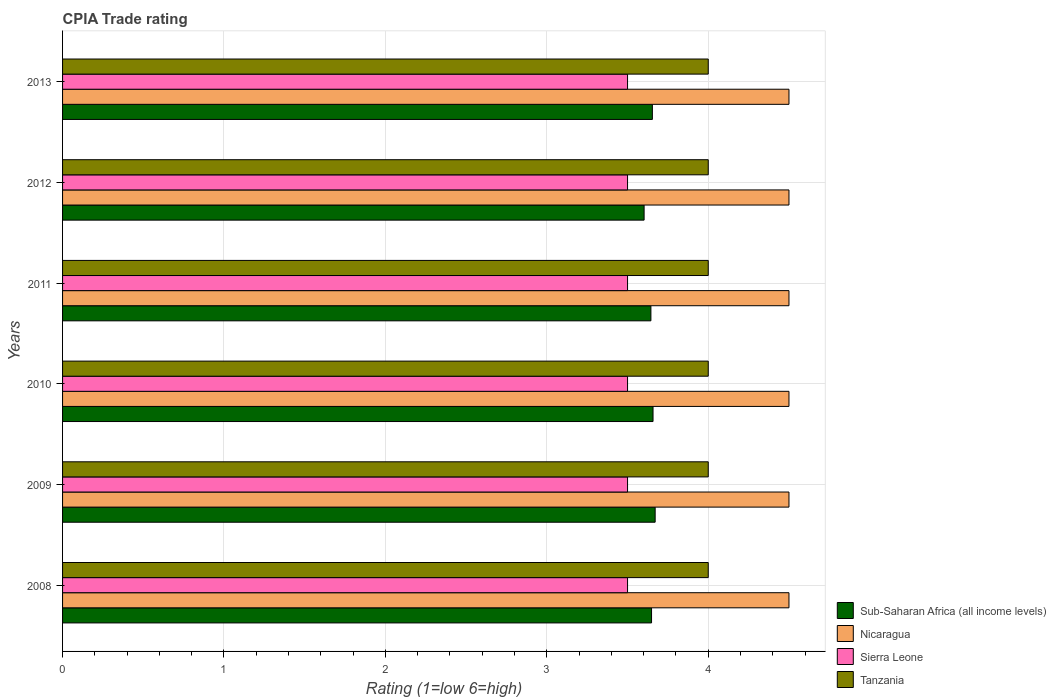How many groups of bars are there?
Ensure brevity in your answer.  6. Are the number of bars per tick equal to the number of legend labels?
Make the answer very short. Yes. How many bars are there on the 5th tick from the top?
Provide a succinct answer. 4. In how many cases, is the number of bars for a given year not equal to the number of legend labels?
Offer a terse response. 0. What is the CPIA rating in Sub-Saharan Africa (all income levels) in 2010?
Provide a succinct answer. 3.66. Across all years, what is the maximum CPIA rating in Tanzania?
Provide a short and direct response. 4. What is the difference between the CPIA rating in Sub-Saharan Africa (all income levels) in 2011 and that in 2013?
Ensure brevity in your answer.  -0.01. What is the difference between the CPIA rating in Sub-Saharan Africa (all income levels) in 2010 and the CPIA rating in Tanzania in 2012?
Offer a terse response. -0.34. What is the average CPIA rating in Sub-Saharan Africa (all income levels) per year?
Offer a very short reply. 3.65. In the year 2013, what is the difference between the CPIA rating in Tanzania and CPIA rating in Nicaragua?
Offer a terse response. -0.5. What is the difference between the highest and the second highest CPIA rating in Sierra Leone?
Offer a terse response. 0. What is the difference between the highest and the lowest CPIA rating in Nicaragua?
Your answer should be very brief. 0. In how many years, is the CPIA rating in Tanzania greater than the average CPIA rating in Tanzania taken over all years?
Provide a short and direct response. 0. What does the 3rd bar from the top in 2013 represents?
Give a very brief answer. Nicaragua. What does the 4th bar from the bottom in 2010 represents?
Your answer should be compact. Tanzania. Are all the bars in the graph horizontal?
Keep it short and to the point. Yes. How many years are there in the graph?
Make the answer very short. 6. Are the values on the major ticks of X-axis written in scientific E-notation?
Ensure brevity in your answer.  No. Does the graph contain grids?
Your answer should be very brief. Yes. Where does the legend appear in the graph?
Your response must be concise. Bottom right. How are the legend labels stacked?
Provide a succinct answer. Vertical. What is the title of the graph?
Provide a short and direct response. CPIA Trade rating. What is the label or title of the Y-axis?
Offer a terse response. Years. What is the Rating (1=low 6=high) in Sub-Saharan Africa (all income levels) in 2008?
Give a very brief answer. 3.65. What is the Rating (1=low 6=high) of Sub-Saharan Africa (all income levels) in 2009?
Provide a succinct answer. 3.67. What is the Rating (1=low 6=high) of Sierra Leone in 2009?
Offer a very short reply. 3.5. What is the Rating (1=low 6=high) of Sub-Saharan Africa (all income levels) in 2010?
Give a very brief answer. 3.66. What is the Rating (1=low 6=high) in Nicaragua in 2010?
Offer a very short reply. 4.5. What is the Rating (1=low 6=high) of Sierra Leone in 2010?
Provide a succinct answer. 3.5. What is the Rating (1=low 6=high) in Sub-Saharan Africa (all income levels) in 2011?
Keep it short and to the point. 3.64. What is the Rating (1=low 6=high) in Nicaragua in 2011?
Ensure brevity in your answer.  4.5. What is the Rating (1=low 6=high) in Tanzania in 2011?
Your answer should be compact. 4. What is the Rating (1=low 6=high) in Sub-Saharan Africa (all income levels) in 2012?
Provide a succinct answer. 3.6. What is the Rating (1=low 6=high) in Nicaragua in 2012?
Your response must be concise. 4.5. What is the Rating (1=low 6=high) in Sierra Leone in 2012?
Ensure brevity in your answer.  3.5. What is the Rating (1=low 6=high) of Sub-Saharan Africa (all income levels) in 2013?
Ensure brevity in your answer.  3.65. What is the Rating (1=low 6=high) of Sierra Leone in 2013?
Provide a succinct answer. 3.5. What is the Rating (1=low 6=high) of Tanzania in 2013?
Ensure brevity in your answer.  4. Across all years, what is the maximum Rating (1=low 6=high) in Sub-Saharan Africa (all income levels)?
Your answer should be compact. 3.67. Across all years, what is the maximum Rating (1=low 6=high) in Nicaragua?
Provide a short and direct response. 4.5. Across all years, what is the minimum Rating (1=low 6=high) in Sub-Saharan Africa (all income levels)?
Offer a very short reply. 3.6. Across all years, what is the minimum Rating (1=low 6=high) of Nicaragua?
Keep it short and to the point. 4.5. Across all years, what is the minimum Rating (1=low 6=high) in Sierra Leone?
Your answer should be very brief. 3.5. Across all years, what is the minimum Rating (1=low 6=high) of Tanzania?
Make the answer very short. 4. What is the total Rating (1=low 6=high) in Sub-Saharan Africa (all income levels) in the graph?
Provide a short and direct response. 21.88. What is the total Rating (1=low 6=high) in Nicaragua in the graph?
Make the answer very short. 27. What is the total Rating (1=low 6=high) in Sierra Leone in the graph?
Your answer should be compact. 21. What is the difference between the Rating (1=low 6=high) in Sub-Saharan Africa (all income levels) in 2008 and that in 2009?
Keep it short and to the point. -0.02. What is the difference between the Rating (1=low 6=high) in Nicaragua in 2008 and that in 2009?
Provide a succinct answer. 0. What is the difference between the Rating (1=low 6=high) in Sub-Saharan Africa (all income levels) in 2008 and that in 2010?
Your answer should be compact. -0.01. What is the difference between the Rating (1=low 6=high) in Nicaragua in 2008 and that in 2010?
Offer a terse response. 0. What is the difference between the Rating (1=low 6=high) of Sierra Leone in 2008 and that in 2010?
Your answer should be compact. 0. What is the difference between the Rating (1=low 6=high) of Sub-Saharan Africa (all income levels) in 2008 and that in 2011?
Provide a succinct answer. 0. What is the difference between the Rating (1=low 6=high) of Nicaragua in 2008 and that in 2011?
Give a very brief answer. 0. What is the difference between the Rating (1=low 6=high) in Sierra Leone in 2008 and that in 2011?
Make the answer very short. 0. What is the difference between the Rating (1=low 6=high) of Sub-Saharan Africa (all income levels) in 2008 and that in 2012?
Make the answer very short. 0.05. What is the difference between the Rating (1=low 6=high) in Sub-Saharan Africa (all income levels) in 2008 and that in 2013?
Ensure brevity in your answer.  -0.01. What is the difference between the Rating (1=low 6=high) of Sierra Leone in 2008 and that in 2013?
Offer a very short reply. 0. What is the difference between the Rating (1=low 6=high) in Tanzania in 2008 and that in 2013?
Your answer should be compact. 0. What is the difference between the Rating (1=low 6=high) in Sub-Saharan Africa (all income levels) in 2009 and that in 2010?
Keep it short and to the point. 0.01. What is the difference between the Rating (1=low 6=high) of Sierra Leone in 2009 and that in 2010?
Offer a very short reply. 0. What is the difference between the Rating (1=low 6=high) of Tanzania in 2009 and that in 2010?
Make the answer very short. 0. What is the difference between the Rating (1=low 6=high) in Sub-Saharan Africa (all income levels) in 2009 and that in 2011?
Make the answer very short. 0.03. What is the difference between the Rating (1=low 6=high) of Nicaragua in 2009 and that in 2011?
Provide a short and direct response. 0. What is the difference between the Rating (1=low 6=high) of Tanzania in 2009 and that in 2011?
Provide a succinct answer. 0. What is the difference between the Rating (1=low 6=high) in Sub-Saharan Africa (all income levels) in 2009 and that in 2012?
Ensure brevity in your answer.  0.07. What is the difference between the Rating (1=low 6=high) in Nicaragua in 2009 and that in 2012?
Make the answer very short. 0. What is the difference between the Rating (1=low 6=high) in Sierra Leone in 2009 and that in 2012?
Provide a short and direct response. 0. What is the difference between the Rating (1=low 6=high) in Sub-Saharan Africa (all income levels) in 2009 and that in 2013?
Give a very brief answer. 0.02. What is the difference between the Rating (1=low 6=high) of Nicaragua in 2009 and that in 2013?
Offer a very short reply. 0. What is the difference between the Rating (1=low 6=high) in Sierra Leone in 2009 and that in 2013?
Offer a very short reply. 0. What is the difference between the Rating (1=low 6=high) of Sub-Saharan Africa (all income levels) in 2010 and that in 2011?
Offer a very short reply. 0.01. What is the difference between the Rating (1=low 6=high) of Sierra Leone in 2010 and that in 2011?
Make the answer very short. 0. What is the difference between the Rating (1=low 6=high) of Tanzania in 2010 and that in 2011?
Provide a short and direct response. 0. What is the difference between the Rating (1=low 6=high) in Sub-Saharan Africa (all income levels) in 2010 and that in 2012?
Your response must be concise. 0.06. What is the difference between the Rating (1=low 6=high) in Nicaragua in 2010 and that in 2012?
Offer a terse response. 0. What is the difference between the Rating (1=low 6=high) in Sierra Leone in 2010 and that in 2012?
Give a very brief answer. 0. What is the difference between the Rating (1=low 6=high) in Tanzania in 2010 and that in 2012?
Make the answer very short. 0. What is the difference between the Rating (1=low 6=high) in Sub-Saharan Africa (all income levels) in 2010 and that in 2013?
Ensure brevity in your answer.  0. What is the difference between the Rating (1=low 6=high) in Sierra Leone in 2010 and that in 2013?
Your answer should be very brief. 0. What is the difference between the Rating (1=low 6=high) in Tanzania in 2010 and that in 2013?
Your answer should be compact. 0. What is the difference between the Rating (1=low 6=high) of Sub-Saharan Africa (all income levels) in 2011 and that in 2012?
Give a very brief answer. 0.04. What is the difference between the Rating (1=low 6=high) of Tanzania in 2011 and that in 2012?
Give a very brief answer. 0. What is the difference between the Rating (1=low 6=high) of Sub-Saharan Africa (all income levels) in 2011 and that in 2013?
Offer a terse response. -0.01. What is the difference between the Rating (1=low 6=high) in Nicaragua in 2011 and that in 2013?
Offer a terse response. 0. What is the difference between the Rating (1=low 6=high) in Sierra Leone in 2011 and that in 2013?
Provide a short and direct response. 0. What is the difference between the Rating (1=low 6=high) of Tanzania in 2011 and that in 2013?
Provide a succinct answer. 0. What is the difference between the Rating (1=low 6=high) of Sub-Saharan Africa (all income levels) in 2012 and that in 2013?
Offer a very short reply. -0.05. What is the difference between the Rating (1=low 6=high) of Tanzania in 2012 and that in 2013?
Your answer should be compact. 0. What is the difference between the Rating (1=low 6=high) of Sub-Saharan Africa (all income levels) in 2008 and the Rating (1=low 6=high) of Nicaragua in 2009?
Offer a very short reply. -0.85. What is the difference between the Rating (1=low 6=high) of Sub-Saharan Africa (all income levels) in 2008 and the Rating (1=low 6=high) of Sierra Leone in 2009?
Offer a terse response. 0.15. What is the difference between the Rating (1=low 6=high) in Sub-Saharan Africa (all income levels) in 2008 and the Rating (1=low 6=high) in Tanzania in 2009?
Provide a succinct answer. -0.35. What is the difference between the Rating (1=low 6=high) of Sub-Saharan Africa (all income levels) in 2008 and the Rating (1=low 6=high) of Nicaragua in 2010?
Give a very brief answer. -0.85. What is the difference between the Rating (1=low 6=high) in Sub-Saharan Africa (all income levels) in 2008 and the Rating (1=low 6=high) in Sierra Leone in 2010?
Offer a terse response. 0.15. What is the difference between the Rating (1=low 6=high) of Sub-Saharan Africa (all income levels) in 2008 and the Rating (1=low 6=high) of Tanzania in 2010?
Your answer should be compact. -0.35. What is the difference between the Rating (1=low 6=high) of Sub-Saharan Africa (all income levels) in 2008 and the Rating (1=low 6=high) of Nicaragua in 2011?
Give a very brief answer. -0.85. What is the difference between the Rating (1=low 6=high) of Sub-Saharan Africa (all income levels) in 2008 and the Rating (1=low 6=high) of Sierra Leone in 2011?
Ensure brevity in your answer.  0.15. What is the difference between the Rating (1=low 6=high) of Sub-Saharan Africa (all income levels) in 2008 and the Rating (1=low 6=high) of Tanzania in 2011?
Offer a terse response. -0.35. What is the difference between the Rating (1=low 6=high) in Nicaragua in 2008 and the Rating (1=low 6=high) in Sierra Leone in 2011?
Make the answer very short. 1. What is the difference between the Rating (1=low 6=high) of Nicaragua in 2008 and the Rating (1=low 6=high) of Tanzania in 2011?
Keep it short and to the point. 0.5. What is the difference between the Rating (1=low 6=high) of Sub-Saharan Africa (all income levels) in 2008 and the Rating (1=low 6=high) of Nicaragua in 2012?
Provide a short and direct response. -0.85. What is the difference between the Rating (1=low 6=high) of Sub-Saharan Africa (all income levels) in 2008 and the Rating (1=low 6=high) of Sierra Leone in 2012?
Offer a terse response. 0.15. What is the difference between the Rating (1=low 6=high) in Sub-Saharan Africa (all income levels) in 2008 and the Rating (1=low 6=high) in Tanzania in 2012?
Your answer should be very brief. -0.35. What is the difference between the Rating (1=low 6=high) in Nicaragua in 2008 and the Rating (1=low 6=high) in Sierra Leone in 2012?
Give a very brief answer. 1. What is the difference between the Rating (1=low 6=high) in Sierra Leone in 2008 and the Rating (1=low 6=high) in Tanzania in 2012?
Offer a very short reply. -0.5. What is the difference between the Rating (1=low 6=high) of Sub-Saharan Africa (all income levels) in 2008 and the Rating (1=low 6=high) of Nicaragua in 2013?
Your answer should be compact. -0.85. What is the difference between the Rating (1=low 6=high) of Sub-Saharan Africa (all income levels) in 2008 and the Rating (1=low 6=high) of Sierra Leone in 2013?
Offer a very short reply. 0.15. What is the difference between the Rating (1=low 6=high) in Sub-Saharan Africa (all income levels) in 2008 and the Rating (1=low 6=high) in Tanzania in 2013?
Provide a succinct answer. -0.35. What is the difference between the Rating (1=low 6=high) in Nicaragua in 2008 and the Rating (1=low 6=high) in Sierra Leone in 2013?
Make the answer very short. 1. What is the difference between the Rating (1=low 6=high) in Nicaragua in 2008 and the Rating (1=low 6=high) in Tanzania in 2013?
Keep it short and to the point. 0.5. What is the difference between the Rating (1=low 6=high) of Sierra Leone in 2008 and the Rating (1=low 6=high) of Tanzania in 2013?
Provide a short and direct response. -0.5. What is the difference between the Rating (1=low 6=high) of Sub-Saharan Africa (all income levels) in 2009 and the Rating (1=low 6=high) of Nicaragua in 2010?
Offer a very short reply. -0.83. What is the difference between the Rating (1=low 6=high) of Sub-Saharan Africa (all income levels) in 2009 and the Rating (1=low 6=high) of Sierra Leone in 2010?
Offer a terse response. 0.17. What is the difference between the Rating (1=low 6=high) of Sub-Saharan Africa (all income levels) in 2009 and the Rating (1=low 6=high) of Tanzania in 2010?
Make the answer very short. -0.33. What is the difference between the Rating (1=low 6=high) of Nicaragua in 2009 and the Rating (1=low 6=high) of Sierra Leone in 2010?
Your response must be concise. 1. What is the difference between the Rating (1=low 6=high) in Nicaragua in 2009 and the Rating (1=low 6=high) in Tanzania in 2010?
Give a very brief answer. 0.5. What is the difference between the Rating (1=low 6=high) in Sierra Leone in 2009 and the Rating (1=low 6=high) in Tanzania in 2010?
Give a very brief answer. -0.5. What is the difference between the Rating (1=low 6=high) of Sub-Saharan Africa (all income levels) in 2009 and the Rating (1=low 6=high) of Nicaragua in 2011?
Offer a very short reply. -0.83. What is the difference between the Rating (1=low 6=high) in Sub-Saharan Africa (all income levels) in 2009 and the Rating (1=low 6=high) in Sierra Leone in 2011?
Make the answer very short. 0.17. What is the difference between the Rating (1=low 6=high) of Sub-Saharan Africa (all income levels) in 2009 and the Rating (1=low 6=high) of Tanzania in 2011?
Offer a very short reply. -0.33. What is the difference between the Rating (1=low 6=high) of Sierra Leone in 2009 and the Rating (1=low 6=high) of Tanzania in 2011?
Ensure brevity in your answer.  -0.5. What is the difference between the Rating (1=low 6=high) in Sub-Saharan Africa (all income levels) in 2009 and the Rating (1=low 6=high) in Nicaragua in 2012?
Your answer should be compact. -0.83. What is the difference between the Rating (1=low 6=high) of Sub-Saharan Africa (all income levels) in 2009 and the Rating (1=low 6=high) of Sierra Leone in 2012?
Your answer should be compact. 0.17. What is the difference between the Rating (1=low 6=high) of Sub-Saharan Africa (all income levels) in 2009 and the Rating (1=low 6=high) of Tanzania in 2012?
Provide a short and direct response. -0.33. What is the difference between the Rating (1=low 6=high) of Nicaragua in 2009 and the Rating (1=low 6=high) of Tanzania in 2012?
Give a very brief answer. 0.5. What is the difference between the Rating (1=low 6=high) in Sub-Saharan Africa (all income levels) in 2009 and the Rating (1=low 6=high) in Nicaragua in 2013?
Keep it short and to the point. -0.83. What is the difference between the Rating (1=low 6=high) of Sub-Saharan Africa (all income levels) in 2009 and the Rating (1=low 6=high) of Sierra Leone in 2013?
Offer a terse response. 0.17. What is the difference between the Rating (1=low 6=high) of Sub-Saharan Africa (all income levels) in 2009 and the Rating (1=low 6=high) of Tanzania in 2013?
Provide a short and direct response. -0.33. What is the difference between the Rating (1=low 6=high) of Nicaragua in 2009 and the Rating (1=low 6=high) of Sierra Leone in 2013?
Give a very brief answer. 1. What is the difference between the Rating (1=low 6=high) in Sub-Saharan Africa (all income levels) in 2010 and the Rating (1=low 6=high) in Nicaragua in 2011?
Your answer should be very brief. -0.84. What is the difference between the Rating (1=low 6=high) of Sub-Saharan Africa (all income levels) in 2010 and the Rating (1=low 6=high) of Sierra Leone in 2011?
Your answer should be compact. 0.16. What is the difference between the Rating (1=low 6=high) in Sub-Saharan Africa (all income levels) in 2010 and the Rating (1=low 6=high) in Tanzania in 2011?
Keep it short and to the point. -0.34. What is the difference between the Rating (1=low 6=high) of Nicaragua in 2010 and the Rating (1=low 6=high) of Sierra Leone in 2011?
Ensure brevity in your answer.  1. What is the difference between the Rating (1=low 6=high) of Sierra Leone in 2010 and the Rating (1=low 6=high) of Tanzania in 2011?
Give a very brief answer. -0.5. What is the difference between the Rating (1=low 6=high) of Sub-Saharan Africa (all income levels) in 2010 and the Rating (1=low 6=high) of Nicaragua in 2012?
Your answer should be compact. -0.84. What is the difference between the Rating (1=low 6=high) of Sub-Saharan Africa (all income levels) in 2010 and the Rating (1=low 6=high) of Sierra Leone in 2012?
Provide a short and direct response. 0.16. What is the difference between the Rating (1=low 6=high) in Sub-Saharan Africa (all income levels) in 2010 and the Rating (1=low 6=high) in Tanzania in 2012?
Ensure brevity in your answer.  -0.34. What is the difference between the Rating (1=low 6=high) in Nicaragua in 2010 and the Rating (1=low 6=high) in Sierra Leone in 2012?
Offer a terse response. 1. What is the difference between the Rating (1=low 6=high) in Sub-Saharan Africa (all income levels) in 2010 and the Rating (1=low 6=high) in Nicaragua in 2013?
Offer a very short reply. -0.84. What is the difference between the Rating (1=low 6=high) in Sub-Saharan Africa (all income levels) in 2010 and the Rating (1=low 6=high) in Sierra Leone in 2013?
Offer a terse response. 0.16. What is the difference between the Rating (1=low 6=high) of Sub-Saharan Africa (all income levels) in 2010 and the Rating (1=low 6=high) of Tanzania in 2013?
Your answer should be compact. -0.34. What is the difference between the Rating (1=low 6=high) in Nicaragua in 2010 and the Rating (1=low 6=high) in Sierra Leone in 2013?
Provide a short and direct response. 1. What is the difference between the Rating (1=low 6=high) in Sierra Leone in 2010 and the Rating (1=low 6=high) in Tanzania in 2013?
Your answer should be compact. -0.5. What is the difference between the Rating (1=low 6=high) of Sub-Saharan Africa (all income levels) in 2011 and the Rating (1=low 6=high) of Nicaragua in 2012?
Offer a terse response. -0.86. What is the difference between the Rating (1=low 6=high) in Sub-Saharan Africa (all income levels) in 2011 and the Rating (1=low 6=high) in Sierra Leone in 2012?
Provide a short and direct response. 0.14. What is the difference between the Rating (1=low 6=high) in Sub-Saharan Africa (all income levels) in 2011 and the Rating (1=low 6=high) in Tanzania in 2012?
Keep it short and to the point. -0.36. What is the difference between the Rating (1=low 6=high) of Nicaragua in 2011 and the Rating (1=low 6=high) of Tanzania in 2012?
Ensure brevity in your answer.  0.5. What is the difference between the Rating (1=low 6=high) in Sierra Leone in 2011 and the Rating (1=low 6=high) in Tanzania in 2012?
Provide a succinct answer. -0.5. What is the difference between the Rating (1=low 6=high) in Sub-Saharan Africa (all income levels) in 2011 and the Rating (1=low 6=high) in Nicaragua in 2013?
Provide a succinct answer. -0.86. What is the difference between the Rating (1=low 6=high) of Sub-Saharan Africa (all income levels) in 2011 and the Rating (1=low 6=high) of Sierra Leone in 2013?
Make the answer very short. 0.14. What is the difference between the Rating (1=low 6=high) of Sub-Saharan Africa (all income levels) in 2011 and the Rating (1=low 6=high) of Tanzania in 2013?
Keep it short and to the point. -0.36. What is the difference between the Rating (1=low 6=high) in Nicaragua in 2011 and the Rating (1=low 6=high) in Sierra Leone in 2013?
Your answer should be compact. 1. What is the difference between the Rating (1=low 6=high) in Sierra Leone in 2011 and the Rating (1=low 6=high) in Tanzania in 2013?
Keep it short and to the point. -0.5. What is the difference between the Rating (1=low 6=high) in Sub-Saharan Africa (all income levels) in 2012 and the Rating (1=low 6=high) in Nicaragua in 2013?
Give a very brief answer. -0.9. What is the difference between the Rating (1=low 6=high) of Sub-Saharan Africa (all income levels) in 2012 and the Rating (1=low 6=high) of Sierra Leone in 2013?
Your answer should be compact. 0.1. What is the difference between the Rating (1=low 6=high) in Sub-Saharan Africa (all income levels) in 2012 and the Rating (1=low 6=high) in Tanzania in 2013?
Provide a short and direct response. -0.4. What is the difference between the Rating (1=low 6=high) in Nicaragua in 2012 and the Rating (1=low 6=high) in Sierra Leone in 2013?
Provide a succinct answer. 1. What is the difference between the Rating (1=low 6=high) in Sierra Leone in 2012 and the Rating (1=low 6=high) in Tanzania in 2013?
Your response must be concise. -0.5. What is the average Rating (1=low 6=high) in Sub-Saharan Africa (all income levels) per year?
Make the answer very short. 3.65. What is the average Rating (1=low 6=high) in Tanzania per year?
Your answer should be very brief. 4. In the year 2008, what is the difference between the Rating (1=low 6=high) in Sub-Saharan Africa (all income levels) and Rating (1=low 6=high) in Nicaragua?
Provide a succinct answer. -0.85. In the year 2008, what is the difference between the Rating (1=low 6=high) in Sub-Saharan Africa (all income levels) and Rating (1=low 6=high) in Sierra Leone?
Provide a short and direct response. 0.15. In the year 2008, what is the difference between the Rating (1=low 6=high) of Sub-Saharan Africa (all income levels) and Rating (1=low 6=high) of Tanzania?
Keep it short and to the point. -0.35. In the year 2008, what is the difference between the Rating (1=low 6=high) in Nicaragua and Rating (1=low 6=high) in Tanzania?
Your answer should be very brief. 0.5. In the year 2008, what is the difference between the Rating (1=low 6=high) in Sierra Leone and Rating (1=low 6=high) in Tanzania?
Your answer should be compact. -0.5. In the year 2009, what is the difference between the Rating (1=low 6=high) of Sub-Saharan Africa (all income levels) and Rating (1=low 6=high) of Nicaragua?
Offer a very short reply. -0.83. In the year 2009, what is the difference between the Rating (1=low 6=high) in Sub-Saharan Africa (all income levels) and Rating (1=low 6=high) in Sierra Leone?
Your response must be concise. 0.17. In the year 2009, what is the difference between the Rating (1=low 6=high) in Sub-Saharan Africa (all income levels) and Rating (1=low 6=high) in Tanzania?
Ensure brevity in your answer.  -0.33. In the year 2010, what is the difference between the Rating (1=low 6=high) of Sub-Saharan Africa (all income levels) and Rating (1=low 6=high) of Nicaragua?
Keep it short and to the point. -0.84. In the year 2010, what is the difference between the Rating (1=low 6=high) of Sub-Saharan Africa (all income levels) and Rating (1=low 6=high) of Sierra Leone?
Provide a succinct answer. 0.16. In the year 2010, what is the difference between the Rating (1=low 6=high) in Sub-Saharan Africa (all income levels) and Rating (1=low 6=high) in Tanzania?
Offer a very short reply. -0.34. In the year 2010, what is the difference between the Rating (1=low 6=high) in Nicaragua and Rating (1=low 6=high) in Sierra Leone?
Your answer should be compact. 1. In the year 2010, what is the difference between the Rating (1=low 6=high) of Nicaragua and Rating (1=low 6=high) of Tanzania?
Offer a terse response. 0.5. In the year 2010, what is the difference between the Rating (1=low 6=high) of Sierra Leone and Rating (1=low 6=high) of Tanzania?
Ensure brevity in your answer.  -0.5. In the year 2011, what is the difference between the Rating (1=low 6=high) of Sub-Saharan Africa (all income levels) and Rating (1=low 6=high) of Nicaragua?
Keep it short and to the point. -0.86. In the year 2011, what is the difference between the Rating (1=low 6=high) in Sub-Saharan Africa (all income levels) and Rating (1=low 6=high) in Sierra Leone?
Keep it short and to the point. 0.14. In the year 2011, what is the difference between the Rating (1=low 6=high) in Sub-Saharan Africa (all income levels) and Rating (1=low 6=high) in Tanzania?
Your response must be concise. -0.36. In the year 2011, what is the difference between the Rating (1=low 6=high) of Nicaragua and Rating (1=low 6=high) of Tanzania?
Give a very brief answer. 0.5. In the year 2011, what is the difference between the Rating (1=low 6=high) in Sierra Leone and Rating (1=low 6=high) in Tanzania?
Give a very brief answer. -0.5. In the year 2012, what is the difference between the Rating (1=low 6=high) in Sub-Saharan Africa (all income levels) and Rating (1=low 6=high) in Nicaragua?
Your answer should be very brief. -0.9. In the year 2012, what is the difference between the Rating (1=low 6=high) of Sub-Saharan Africa (all income levels) and Rating (1=low 6=high) of Sierra Leone?
Provide a succinct answer. 0.1. In the year 2012, what is the difference between the Rating (1=low 6=high) of Sub-Saharan Africa (all income levels) and Rating (1=low 6=high) of Tanzania?
Make the answer very short. -0.4. In the year 2012, what is the difference between the Rating (1=low 6=high) in Nicaragua and Rating (1=low 6=high) in Sierra Leone?
Offer a terse response. 1. In the year 2012, what is the difference between the Rating (1=low 6=high) in Nicaragua and Rating (1=low 6=high) in Tanzania?
Your response must be concise. 0.5. In the year 2013, what is the difference between the Rating (1=low 6=high) of Sub-Saharan Africa (all income levels) and Rating (1=low 6=high) of Nicaragua?
Your answer should be compact. -0.85. In the year 2013, what is the difference between the Rating (1=low 6=high) of Sub-Saharan Africa (all income levels) and Rating (1=low 6=high) of Sierra Leone?
Offer a terse response. 0.15. In the year 2013, what is the difference between the Rating (1=low 6=high) in Sub-Saharan Africa (all income levels) and Rating (1=low 6=high) in Tanzania?
Provide a succinct answer. -0.35. In the year 2013, what is the difference between the Rating (1=low 6=high) in Nicaragua and Rating (1=low 6=high) in Sierra Leone?
Your response must be concise. 1. In the year 2013, what is the difference between the Rating (1=low 6=high) in Nicaragua and Rating (1=low 6=high) in Tanzania?
Provide a succinct answer. 0.5. In the year 2013, what is the difference between the Rating (1=low 6=high) of Sierra Leone and Rating (1=low 6=high) of Tanzania?
Your answer should be very brief. -0.5. What is the ratio of the Rating (1=low 6=high) of Sub-Saharan Africa (all income levels) in 2008 to that in 2009?
Provide a succinct answer. 0.99. What is the ratio of the Rating (1=low 6=high) in Sierra Leone in 2008 to that in 2009?
Ensure brevity in your answer.  1. What is the ratio of the Rating (1=low 6=high) in Tanzania in 2008 to that in 2009?
Keep it short and to the point. 1. What is the ratio of the Rating (1=low 6=high) of Sierra Leone in 2008 to that in 2010?
Ensure brevity in your answer.  1. What is the ratio of the Rating (1=low 6=high) of Sub-Saharan Africa (all income levels) in 2008 to that in 2011?
Ensure brevity in your answer.  1. What is the ratio of the Rating (1=low 6=high) of Sierra Leone in 2008 to that in 2011?
Keep it short and to the point. 1. What is the ratio of the Rating (1=low 6=high) in Sub-Saharan Africa (all income levels) in 2008 to that in 2012?
Your answer should be compact. 1.01. What is the ratio of the Rating (1=low 6=high) of Sierra Leone in 2008 to that in 2013?
Your answer should be very brief. 1. What is the ratio of the Rating (1=low 6=high) of Tanzania in 2008 to that in 2013?
Your answer should be very brief. 1. What is the ratio of the Rating (1=low 6=high) in Sub-Saharan Africa (all income levels) in 2009 to that in 2010?
Your answer should be very brief. 1. What is the ratio of the Rating (1=low 6=high) in Nicaragua in 2009 to that in 2010?
Provide a succinct answer. 1. What is the ratio of the Rating (1=low 6=high) of Sierra Leone in 2009 to that in 2010?
Provide a succinct answer. 1. What is the ratio of the Rating (1=low 6=high) of Tanzania in 2009 to that in 2010?
Keep it short and to the point. 1. What is the ratio of the Rating (1=low 6=high) of Nicaragua in 2009 to that in 2011?
Your response must be concise. 1. What is the ratio of the Rating (1=low 6=high) of Nicaragua in 2009 to that in 2012?
Provide a short and direct response. 1. What is the ratio of the Rating (1=low 6=high) in Sierra Leone in 2009 to that in 2012?
Ensure brevity in your answer.  1. What is the ratio of the Rating (1=low 6=high) of Sierra Leone in 2009 to that in 2013?
Provide a short and direct response. 1. What is the ratio of the Rating (1=low 6=high) of Nicaragua in 2010 to that in 2011?
Provide a short and direct response. 1. What is the ratio of the Rating (1=low 6=high) of Sierra Leone in 2010 to that in 2011?
Provide a short and direct response. 1. What is the ratio of the Rating (1=low 6=high) of Sub-Saharan Africa (all income levels) in 2010 to that in 2012?
Offer a terse response. 1.02. What is the ratio of the Rating (1=low 6=high) of Sierra Leone in 2010 to that in 2012?
Give a very brief answer. 1. What is the ratio of the Rating (1=low 6=high) of Sierra Leone in 2010 to that in 2013?
Provide a succinct answer. 1. What is the ratio of the Rating (1=low 6=high) of Sub-Saharan Africa (all income levels) in 2011 to that in 2012?
Ensure brevity in your answer.  1.01. What is the ratio of the Rating (1=low 6=high) of Nicaragua in 2011 to that in 2012?
Your answer should be very brief. 1. What is the ratio of the Rating (1=low 6=high) in Nicaragua in 2011 to that in 2013?
Provide a short and direct response. 1. What is the ratio of the Rating (1=low 6=high) of Sub-Saharan Africa (all income levels) in 2012 to that in 2013?
Ensure brevity in your answer.  0.99. What is the ratio of the Rating (1=low 6=high) of Sierra Leone in 2012 to that in 2013?
Ensure brevity in your answer.  1. What is the ratio of the Rating (1=low 6=high) of Tanzania in 2012 to that in 2013?
Give a very brief answer. 1. What is the difference between the highest and the second highest Rating (1=low 6=high) in Sub-Saharan Africa (all income levels)?
Provide a short and direct response. 0.01. What is the difference between the highest and the second highest Rating (1=low 6=high) of Tanzania?
Offer a very short reply. 0. What is the difference between the highest and the lowest Rating (1=low 6=high) in Sub-Saharan Africa (all income levels)?
Provide a succinct answer. 0.07. What is the difference between the highest and the lowest Rating (1=low 6=high) in Sierra Leone?
Make the answer very short. 0. 